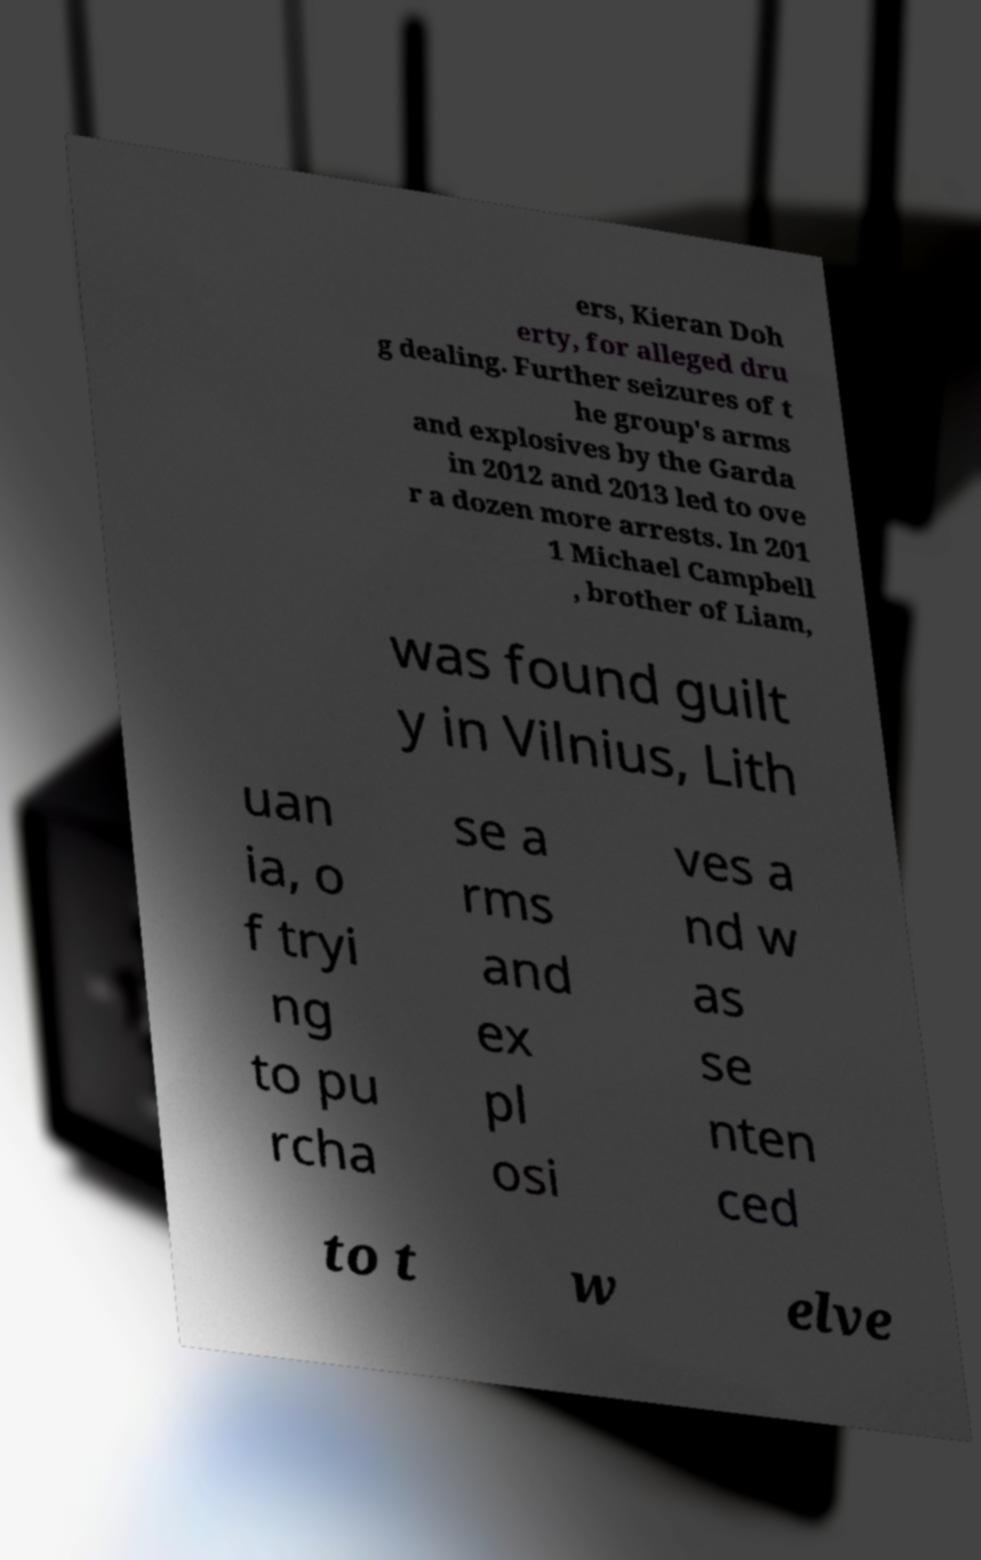For documentation purposes, I need the text within this image transcribed. Could you provide that? ers, Kieran Doh erty, for alleged dru g dealing. Further seizures of t he group's arms and explosives by the Garda in 2012 and 2013 led to ove r a dozen more arrests. In 201 1 Michael Campbell , brother of Liam, was found guilt y in Vilnius, Lith uan ia, o f tryi ng to pu rcha se a rms and ex pl osi ves a nd w as se nten ced to t w elve 